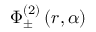Convert formula to latex. <formula><loc_0><loc_0><loc_500><loc_500>\Phi _ { \pm } ^ { ( 2 ) } \left ( r , \alpha \right )</formula> 